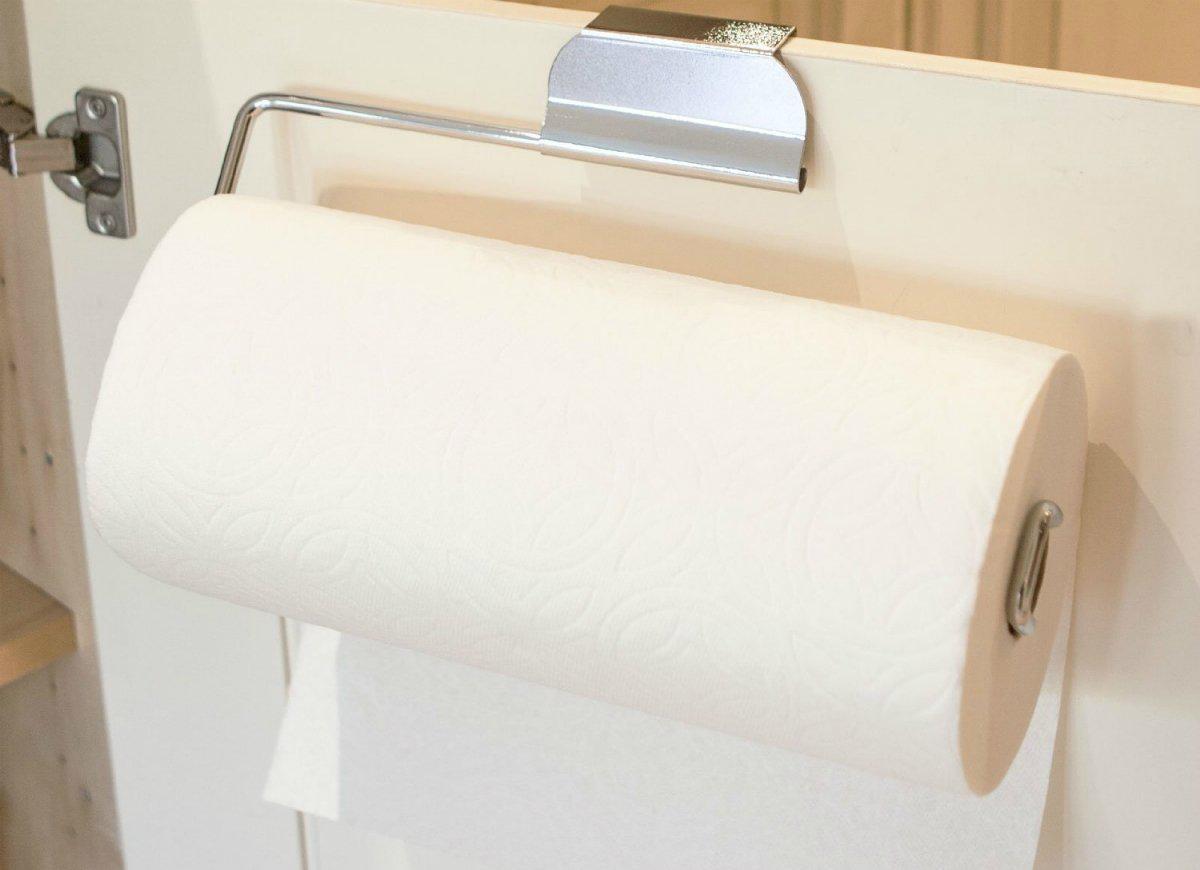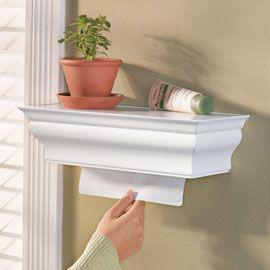The first image is the image on the left, the second image is the image on the right. For the images displayed, is the sentence "At least one image shows a dispenser that is designed to be hung on the wall and fits rectangular napkins." factually correct? Answer yes or no. Yes. 